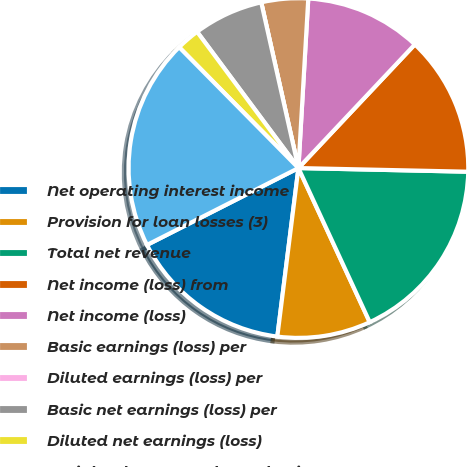<chart> <loc_0><loc_0><loc_500><loc_500><pie_chart><fcel>Net operating interest income<fcel>Provision for loan losses (3)<fcel>Total net revenue<fcel>Net income (loss) from<fcel>Net income (loss)<fcel>Basic earnings (loss) per<fcel>Diluted earnings (loss) per<fcel>Basic net earnings (loss) per<fcel>Diluted net earnings (loss)<fcel>Weighted average shares-basic<nl><fcel>15.54%<fcel>8.88%<fcel>17.76%<fcel>13.32%<fcel>11.1%<fcel>4.44%<fcel>0.0%<fcel>6.66%<fcel>2.22%<fcel>20.08%<nl></chart> 